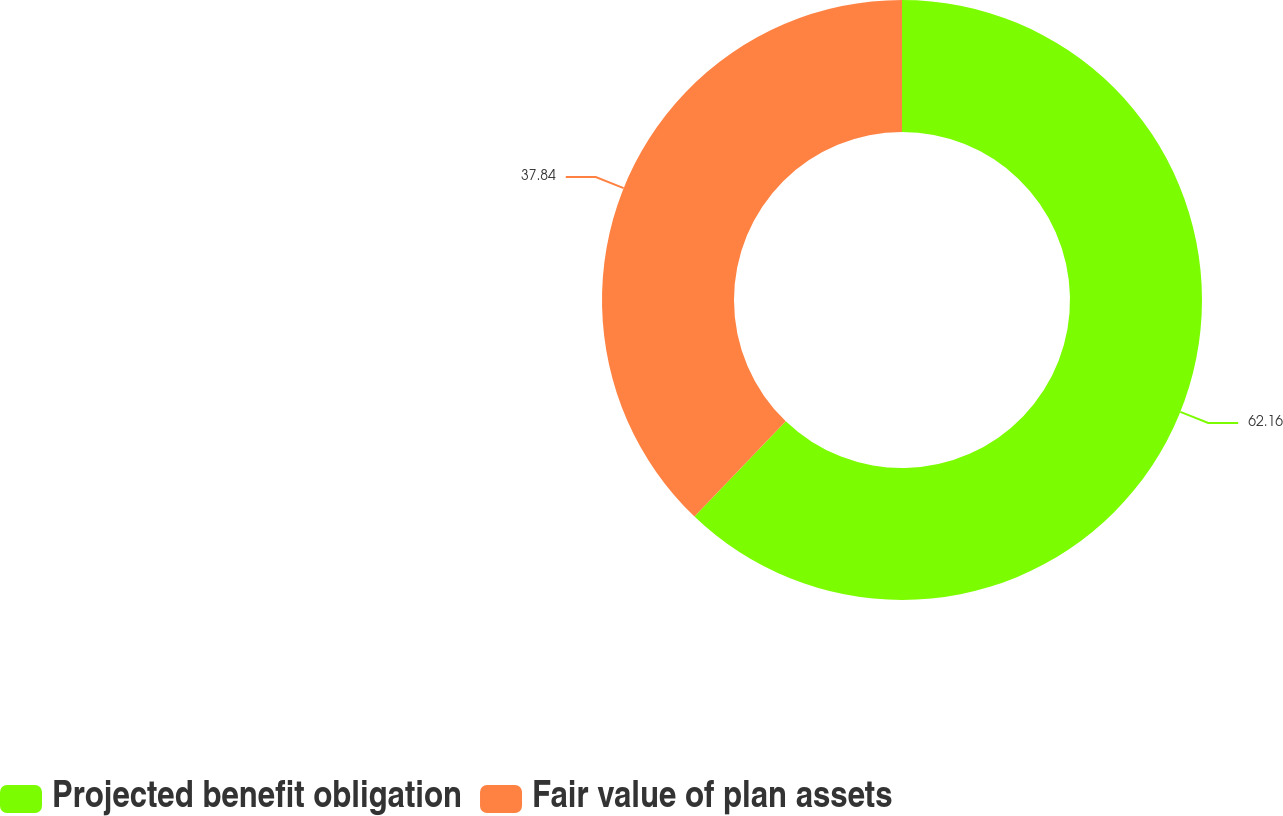Convert chart to OTSL. <chart><loc_0><loc_0><loc_500><loc_500><pie_chart><fcel>Projected benefit obligation<fcel>Fair value of plan assets<nl><fcel>62.16%<fcel>37.84%<nl></chart> 